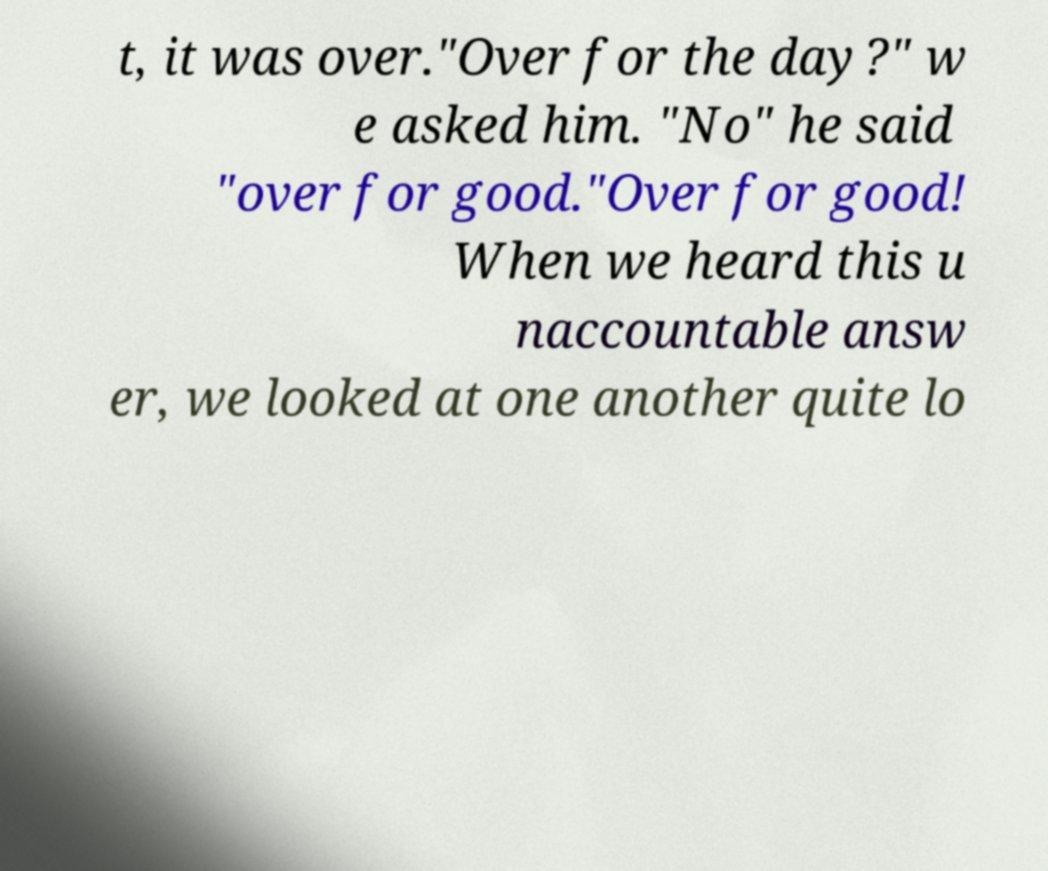Please read and relay the text visible in this image. What does it say? t, it was over."Over for the day?" w e asked him. "No" he said "over for good."Over for good! When we heard this u naccountable answ er, we looked at one another quite lo 